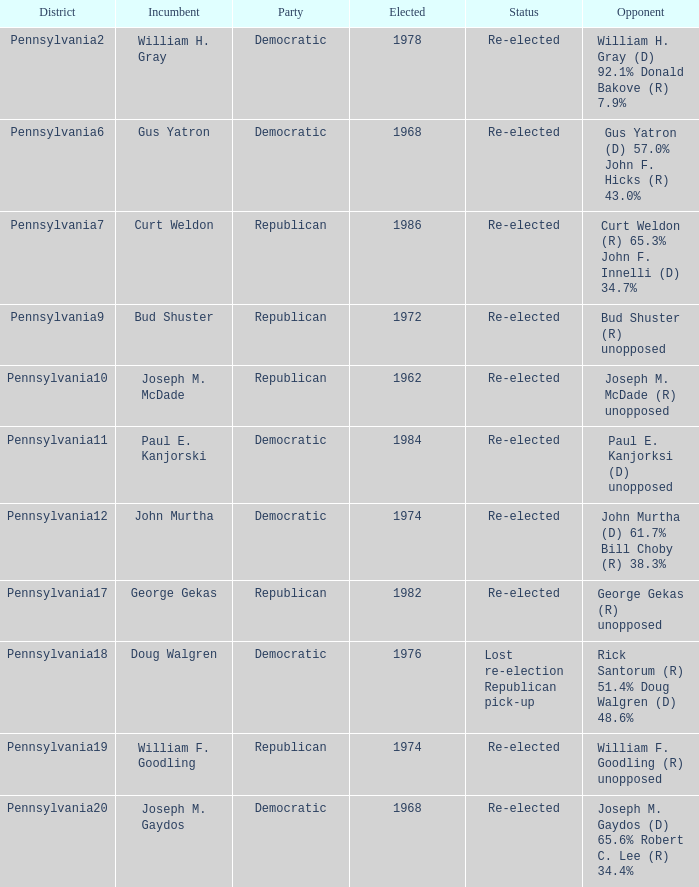Which territories are held by incumbent curt weldon? Pennsylvania7. 